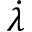Convert formula to latex. <formula><loc_0><loc_0><loc_500><loc_500>\dot { \lambda }</formula> 